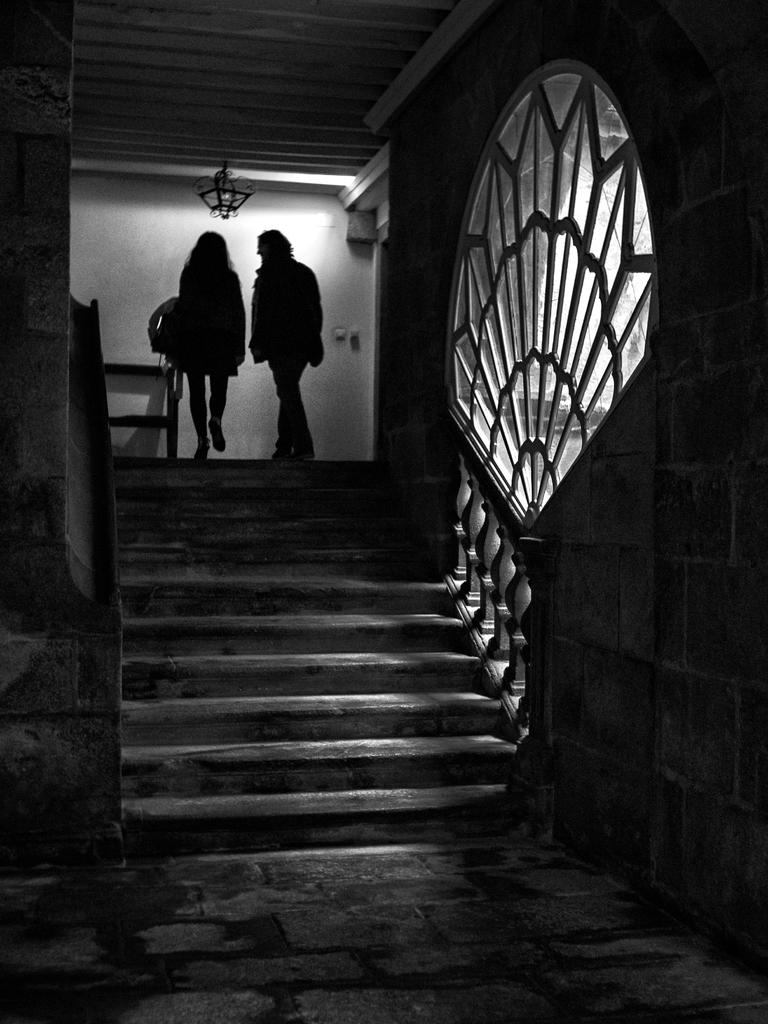How many people are in the image? There are two people in the image. What are the people doing in the image? The two people are walking. Where are the people walking in the image? The people are walking on stairs. What can be seen on the left side of the image? There is a glass window on the left side of the image. How long did the party last in the image? There is no party present in the image, so it is not possible to determine how long it lasted. 